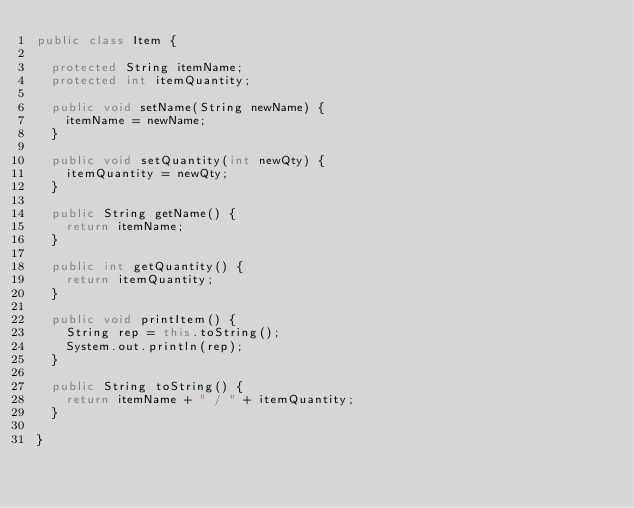<code> <loc_0><loc_0><loc_500><loc_500><_Java_>public class Item {

	protected String itemName;
	protected int itemQuantity;
	
	public void setName(String newName) {
		itemName = newName;
	}

	public void setQuantity(int newQty) {
		itemQuantity = newQty;
	}

	public String getName() {
		return itemName;
	}
	
	public int getQuantity() {
		return itemQuantity;
	}
	
	public void printItem() {
		String rep = this.toString();
		System.out.println(rep);
	}
	
	public String toString() {
		return itemName + " / " + itemQuantity;
	}

}
</code> 